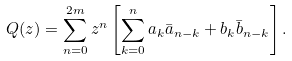<formula> <loc_0><loc_0><loc_500><loc_500>Q ( z ) = \sum _ { n = 0 } ^ { 2 m } z ^ { n } \left [ \sum _ { k = 0 } ^ { n } a _ { k } \bar { a } _ { n - k } + b _ { k } \bar { b } _ { n - k } \right ] .</formula> 